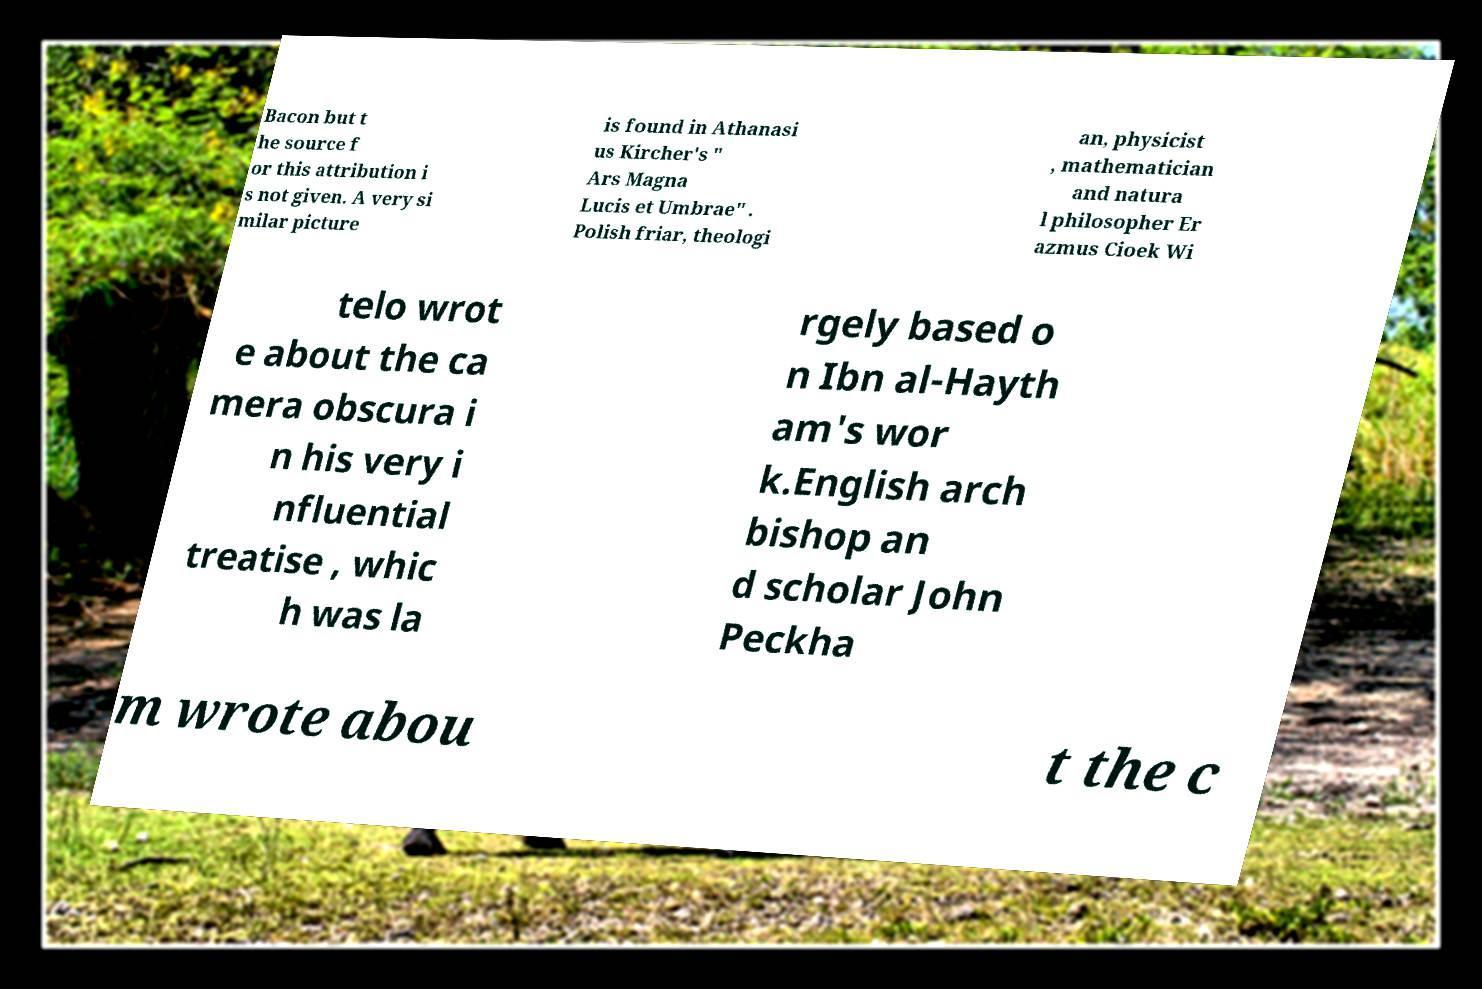I need the written content from this picture converted into text. Can you do that? Bacon but t he source f or this attribution i s not given. A very si milar picture is found in Athanasi us Kircher's " Ars Magna Lucis et Umbrae" . Polish friar, theologi an, physicist , mathematician and natura l philosopher Er azmus Cioek Wi telo wrot e about the ca mera obscura i n his very i nfluential treatise , whic h was la rgely based o n Ibn al-Hayth am's wor k.English arch bishop an d scholar John Peckha m wrote abou t the c 